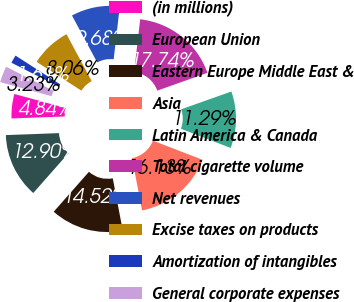<chart> <loc_0><loc_0><loc_500><loc_500><pie_chart><fcel>(in millions)<fcel>European Union<fcel>Eastern Europe Middle East &<fcel>Asia<fcel>Latin America & Canada<fcel>Total cigarette volume<fcel>Net revenues<fcel>Excise taxes on products<fcel>Amortization of intangibles<fcel>General corporate expenses<nl><fcel>4.84%<fcel>12.9%<fcel>14.52%<fcel>16.13%<fcel>11.29%<fcel>17.74%<fcel>9.68%<fcel>8.06%<fcel>1.61%<fcel>3.23%<nl></chart> 